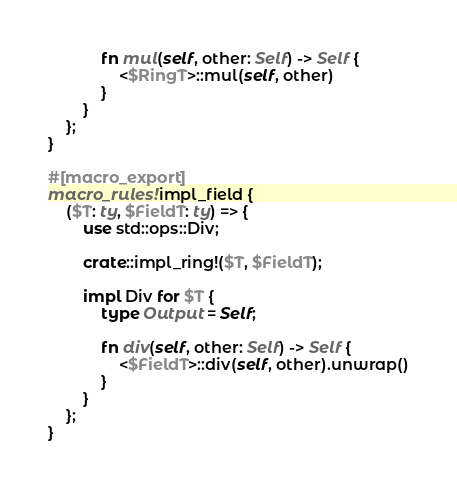Convert code to text. <code><loc_0><loc_0><loc_500><loc_500><_Rust_>            fn mul(self, other: Self) -> Self {
                <$RingT>::mul(self, other)
            }
        }
    };
}

#[macro_export]
macro_rules! impl_field {
    ($T: ty, $FieldT: ty) => {
        use std::ops::Div;

        crate::impl_ring!($T, $FieldT);

        impl Div for $T {
            type Output = Self;

            fn div(self, other: Self) -> Self {
                <$FieldT>::div(self, other).unwrap()
            }
        }
    };
}
</code> 